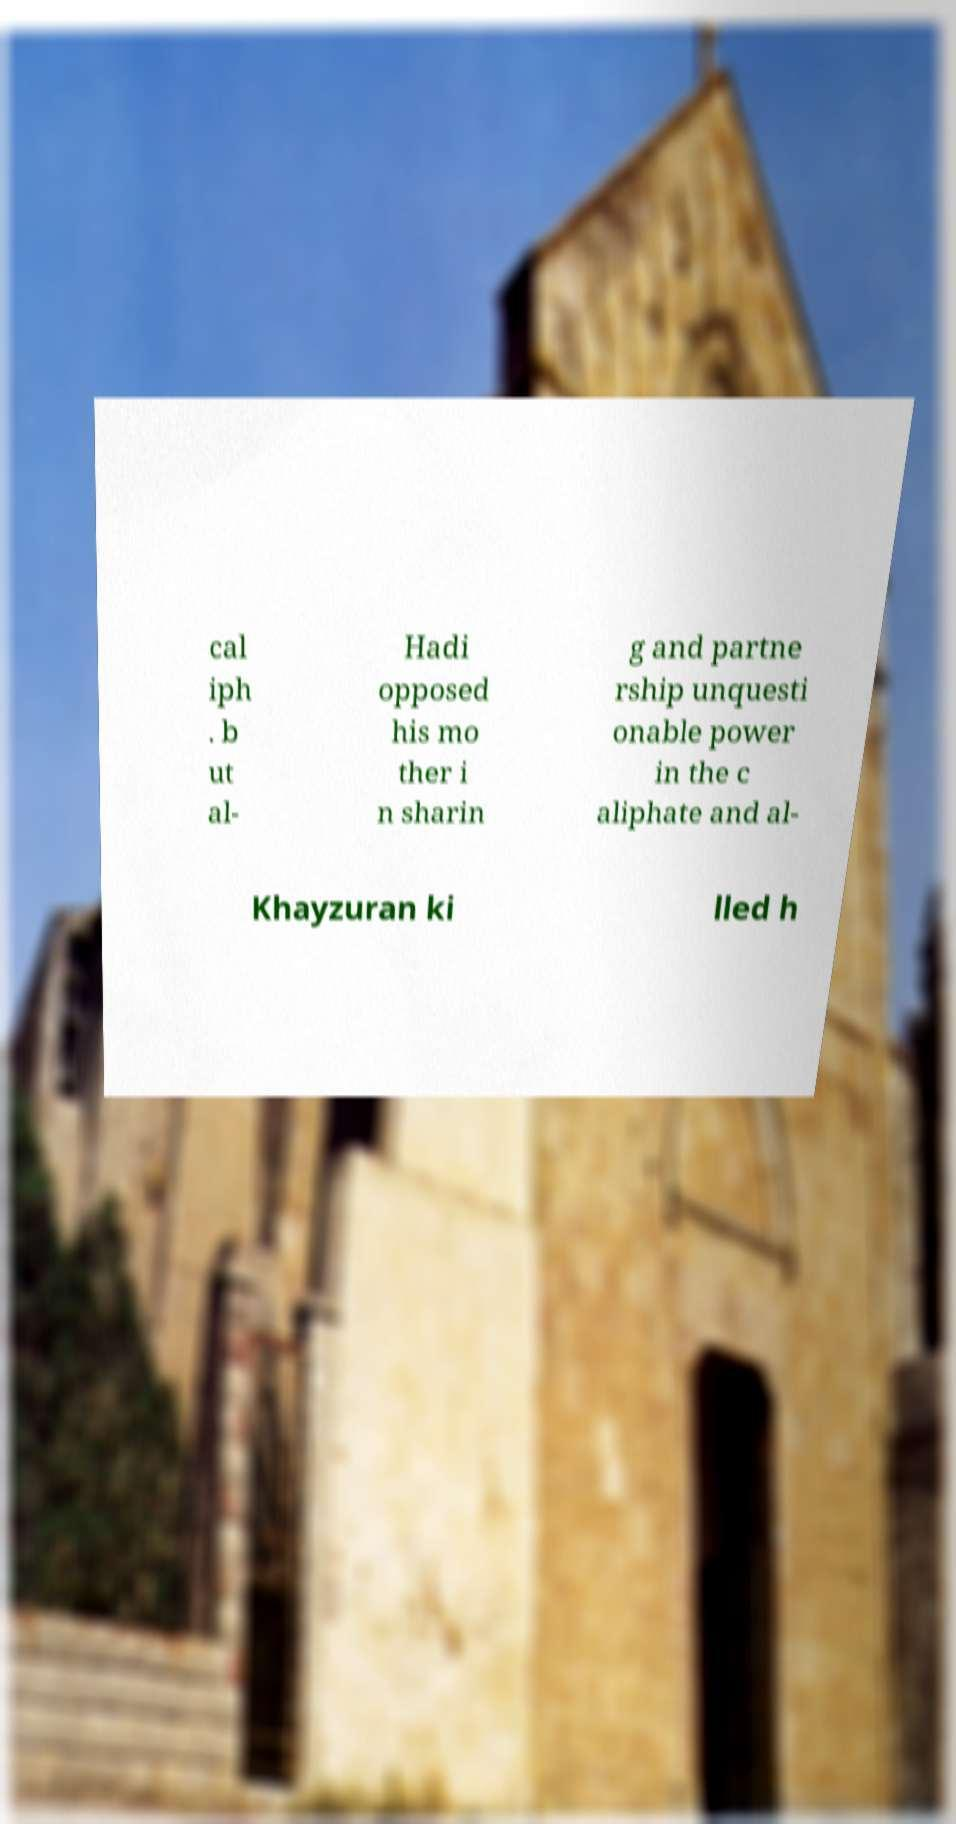Please read and relay the text visible in this image. What does it say? cal iph . b ut al- Hadi opposed his mo ther i n sharin g and partne rship unquesti onable power in the c aliphate and al- Khayzuran ki lled h 